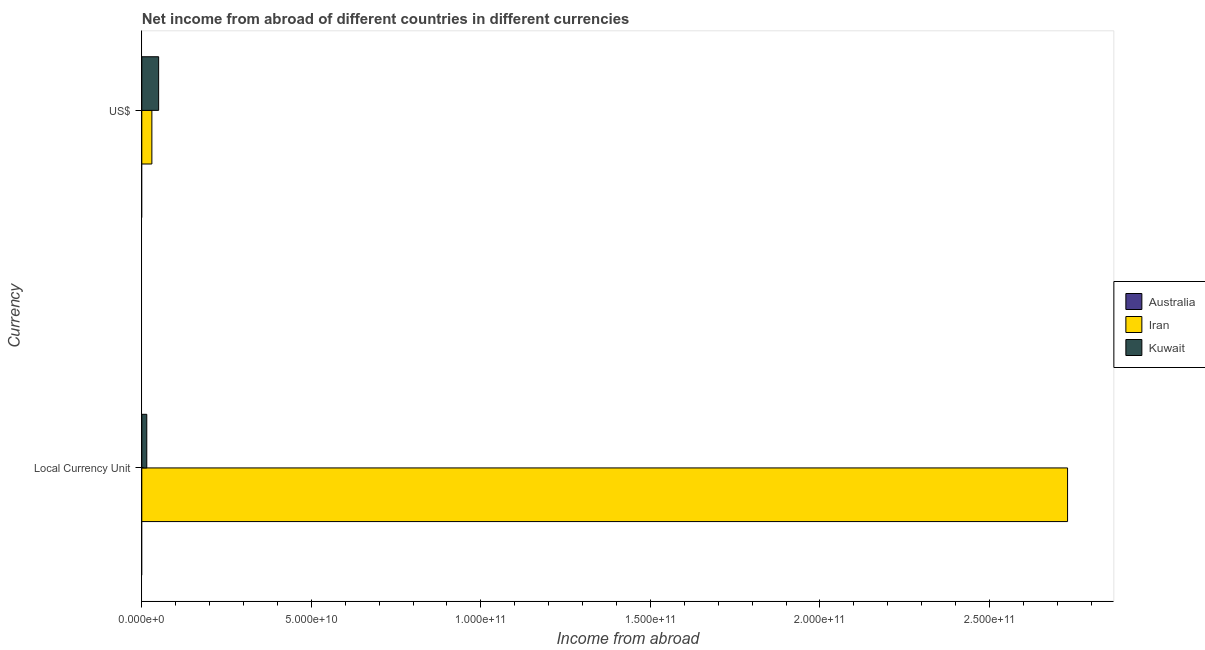How many groups of bars are there?
Give a very brief answer. 2. How many bars are there on the 1st tick from the top?
Make the answer very short. 2. What is the label of the 2nd group of bars from the top?
Your response must be concise. Local Currency Unit. What is the income from abroad in constant 2005 us$ in Iran?
Give a very brief answer. 2.73e+11. Across all countries, what is the maximum income from abroad in constant 2005 us$?
Your answer should be compact. 2.73e+11. In which country was the income from abroad in us$ maximum?
Your response must be concise. Kuwait. What is the total income from abroad in us$ in the graph?
Provide a succinct answer. 7.94e+09. What is the difference between the income from abroad in us$ in Kuwait and that in Iran?
Your answer should be compact. 1.99e+09. What is the difference between the income from abroad in us$ in Iran and the income from abroad in constant 2005 us$ in Australia?
Provide a succinct answer. 2.97e+09. What is the average income from abroad in constant 2005 us$ per country?
Offer a terse response. 9.15e+1. What is the difference between the income from abroad in us$ and income from abroad in constant 2005 us$ in Kuwait?
Give a very brief answer. 3.50e+09. In how many countries, is the income from abroad in constant 2005 us$ greater than 180000000000 units?
Provide a short and direct response. 1. What is the ratio of the income from abroad in constant 2005 us$ in Iran to that in Kuwait?
Provide a short and direct response. 185.72. Is the income from abroad in constant 2005 us$ in Kuwait less than that in Iran?
Ensure brevity in your answer.  Yes. Are the values on the major ticks of X-axis written in scientific E-notation?
Keep it short and to the point. Yes. Does the graph contain grids?
Give a very brief answer. No. How are the legend labels stacked?
Your response must be concise. Vertical. What is the title of the graph?
Provide a succinct answer. Net income from abroad of different countries in different currencies. What is the label or title of the X-axis?
Give a very brief answer. Income from abroad. What is the label or title of the Y-axis?
Provide a short and direct response. Currency. What is the Income from abroad in Australia in Local Currency Unit?
Provide a short and direct response. 0. What is the Income from abroad in Iran in Local Currency Unit?
Provide a succinct answer. 2.73e+11. What is the Income from abroad in Kuwait in Local Currency Unit?
Give a very brief answer. 1.47e+09. What is the Income from abroad of Australia in US$?
Ensure brevity in your answer.  0. What is the Income from abroad in Iran in US$?
Your response must be concise. 2.97e+09. What is the Income from abroad in Kuwait in US$?
Keep it short and to the point. 4.97e+09. Across all Currency, what is the maximum Income from abroad of Iran?
Provide a succinct answer. 2.73e+11. Across all Currency, what is the maximum Income from abroad of Kuwait?
Provide a succinct answer. 4.97e+09. Across all Currency, what is the minimum Income from abroad of Iran?
Your answer should be compact. 2.97e+09. Across all Currency, what is the minimum Income from abroad of Kuwait?
Provide a succinct answer. 1.47e+09. What is the total Income from abroad of Australia in the graph?
Ensure brevity in your answer.  0. What is the total Income from abroad in Iran in the graph?
Ensure brevity in your answer.  2.76e+11. What is the total Income from abroad in Kuwait in the graph?
Offer a terse response. 6.44e+09. What is the difference between the Income from abroad in Iran in Local Currency Unit and that in US$?
Offer a terse response. 2.70e+11. What is the difference between the Income from abroad of Kuwait in Local Currency Unit and that in US$?
Provide a succinct answer. -3.50e+09. What is the difference between the Income from abroad in Iran in Local Currency Unit and the Income from abroad in Kuwait in US$?
Ensure brevity in your answer.  2.68e+11. What is the average Income from abroad of Australia per Currency?
Provide a succinct answer. 0. What is the average Income from abroad of Iran per Currency?
Offer a very short reply. 1.38e+11. What is the average Income from abroad in Kuwait per Currency?
Keep it short and to the point. 3.22e+09. What is the difference between the Income from abroad in Iran and Income from abroad in Kuwait in Local Currency Unit?
Offer a very short reply. 2.72e+11. What is the difference between the Income from abroad in Iran and Income from abroad in Kuwait in US$?
Provide a succinct answer. -1.99e+09. What is the ratio of the Income from abroad of Iran in Local Currency Unit to that in US$?
Your answer should be compact. 91.9. What is the ratio of the Income from abroad of Kuwait in Local Currency Unit to that in US$?
Make the answer very short. 0.3. What is the difference between the highest and the second highest Income from abroad in Iran?
Offer a very short reply. 2.70e+11. What is the difference between the highest and the second highest Income from abroad of Kuwait?
Offer a very short reply. 3.50e+09. What is the difference between the highest and the lowest Income from abroad of Iran?
Make the answer very short. 2.70e+11. What is the difference between the highest and the lowest Income from abroad of Kuwait?
Provide a succinct answer. 3.50e+09. 